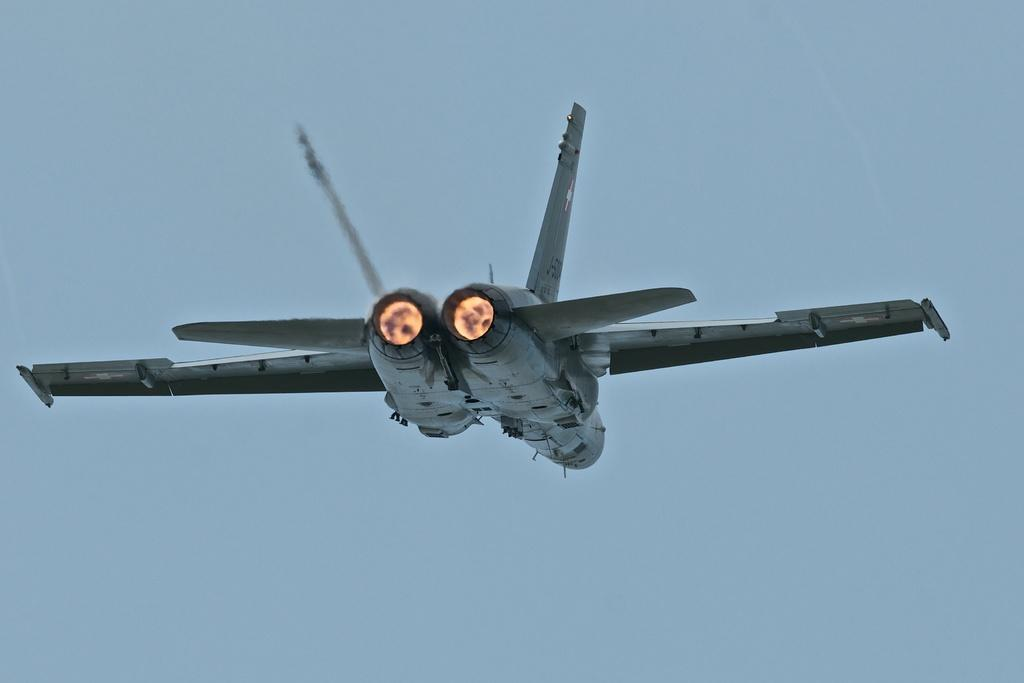What is the main subject of the image? The main subject of the image is aircrafts. What are the aircrafts doing in the image? The aircrafts are flying in the sky. What type of brick is being used to build the root of the tree in the image? There is no brick or tree present in the image; it features aircrafts flying in the sky. How does the stomach of the aircraft affect its flight in the image? Aircrafts do not have stomachs, as they are machines, not living organisms. 